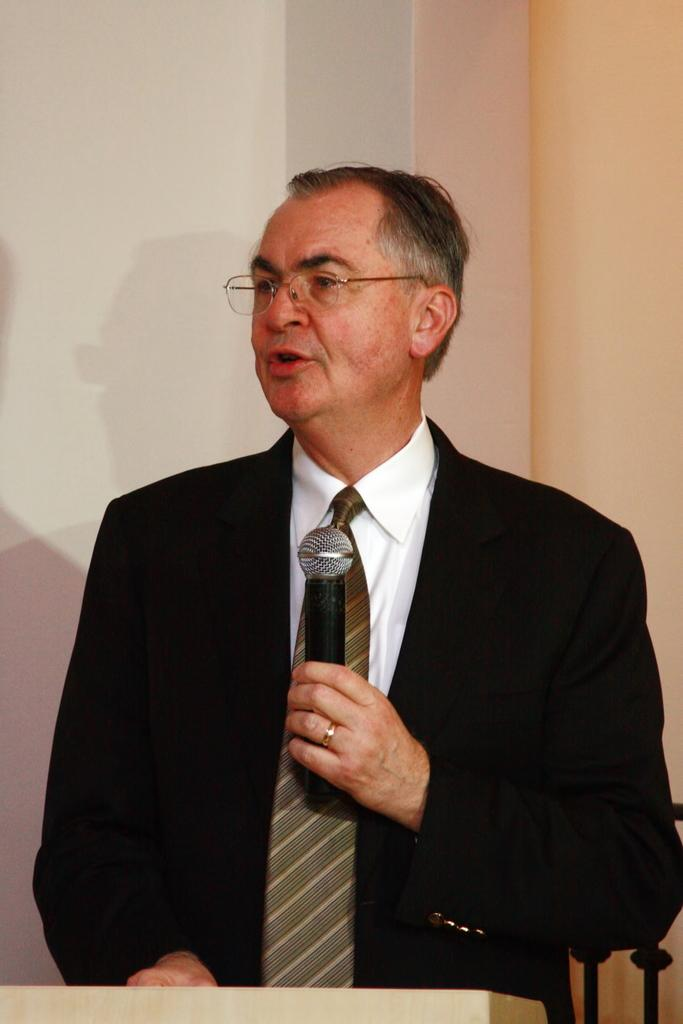What is the main subject of the image? The main subject of the image is a man. What is the man holding in the image? The man is holding a mic in the image. What type of apparel is the man wearing in the image? The provided facts do not mention any specific apparel the man is wearing, so we cannot determine the type of clothing from the image. 